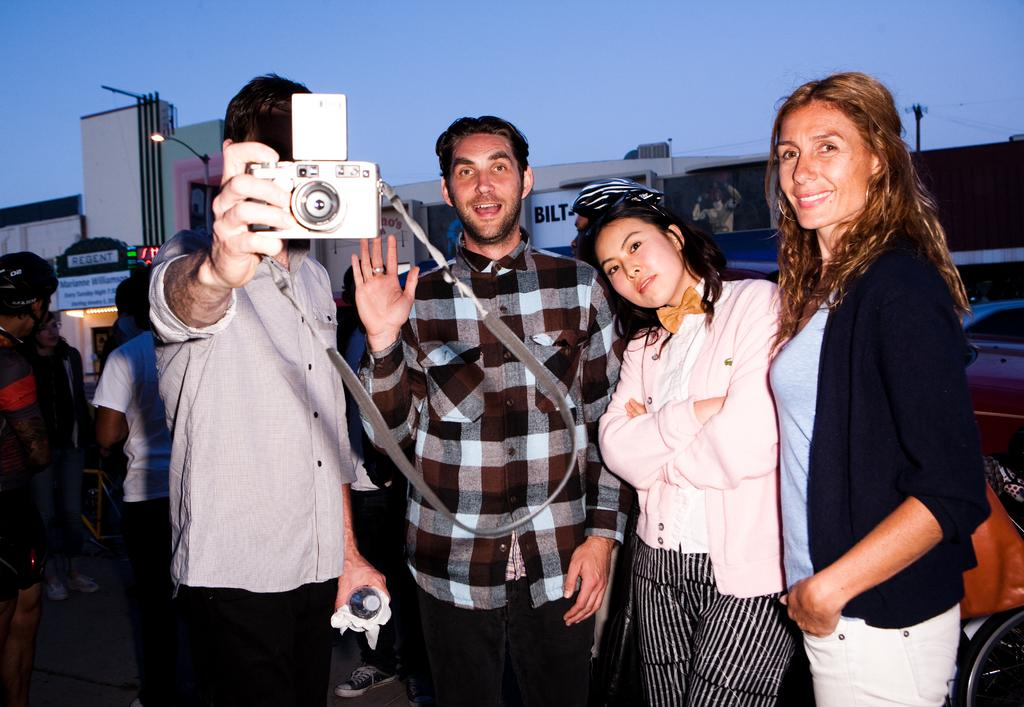How many people are in the image? There are 2 men and 2 women in the image. What is one of the men doing in the image? One man is holding a camera. What is the facial expression of one of the women in the image? One woman is smiling. What can be seen in the background of the image? There are people, at least one building, and a street light in the background of the image. What type of mountain can be seen in the background of the image? There is no mountain visible in the image; it features people, a building, and a street light in the background. What color is the skirt worn by one of the women in the image? There is no skirt present in the image; the women are wearing pants or dresses. 